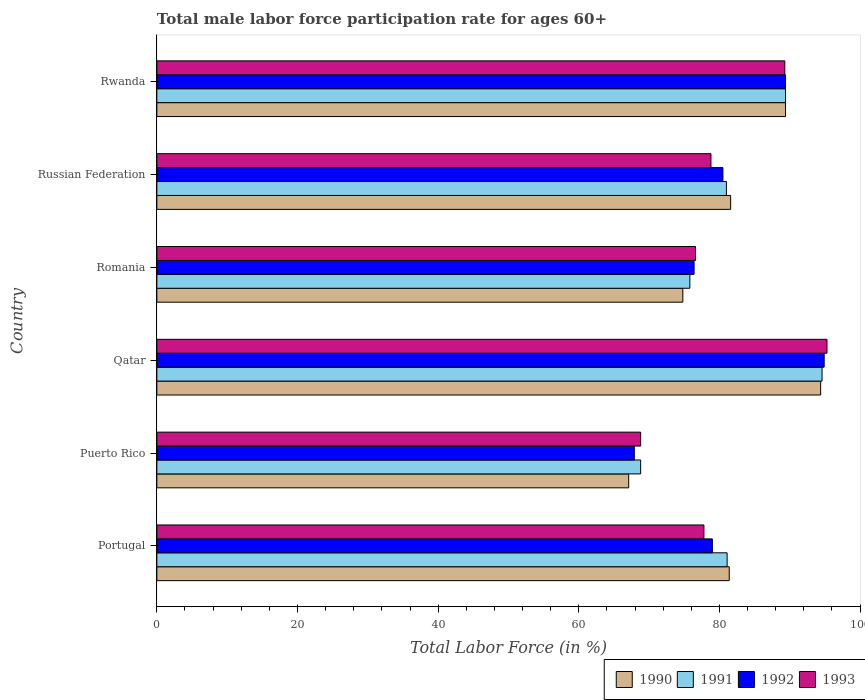How many bars are there on the 5th tick from the top?
Your response must be concise. 4. What is the label of the 1st group of bars from the top?
Ensure brevity in your answer.  Rwanda. What is the male labor force participation rate in 1991 in Portugal?
Your answer should be compact. 81.1. Across all countries, what is the maximum male labor force participation rate in 1991?
Give a very brief answer. 94.6. Across all countries, what is the minimum male labor force participation rate in 1992?
Provide a short and direct response. 67.9. In which country was the male labor force participation rate in 1990 maximum?
Provide a short and direct response. Qatar. In which country was the male labor force participation rate in 1992 minimum?
Keep it short and to the point. Puerto Rico. What is the total male labor force participation rate in 1991 in the graph?
Give a very brief answer. 490.7. What is the difference between the male labor force participation rate in 1990 in Qatar and that in Rwanda?
Make the answer very short. 5. What is the difference between the male labor force participation rate in 1993 in Puerto Rico and the male labor force participation rate in 1991 in Rwanda?
Your answer should be compact. -20.6. What is the average male labor force participation rate in 1992 per country?
Make the answer very short. 81.35. What is the difference between the male labor force participation rate in 1993 and male labor force participation rate in 1990 in Qatar?
Offer a terse response. 0.9. In how many countries, is the male labor force participation rate in 1993 greater than 24 %?
Your answer should be very brief. 6. What is the ratio of the male labor force participation rate in 1992 in Romania to that in Russian Federation?
Your answer should be very brief. 0.95. Is the male labor force participation rate in 1991 in Puerto Rico less than that in Russian Federation?
Keep it short and to the point. Yes. Is the difference between the male labor force participation rate in 1993 in Qatar and Romania greater than the difference between the male labor force participation rate in 1990 in Qatar and Romania?
Offer a very short reply. No. What is the difference between the highest and the lowest male labor force participation rate in 1992?
Provide a short and direct response. 27. What does the 4th bar from the top in Rwanda represents?
Provide a succinct answer. 1990. How many countries are there in the graph?
Offer a terse response. 6. What is the difference between two consecutive major ticks on the X-axis?
Make the answer very short. 20. Does the graph contain grids?
Offer a terse response. No. What is the title of the graph?
Offer a terse response. Total male labor force participation rate for ages 60+. What is the label or title of the X-axis?
Keep it short and to the point. Total Labor Force (in %). What is the Total Labor Force (in %) in 1990 in Portugal?
Your answer should be very brief. 81.4. What is the Total Labor Force (in %) of 1991 in Portugal?
Provide a short and direct response. 81.1. What is the Total Labor Force (in %) of 1992 in Portugal?
Your answer should be compact. 79. What is the Total Labor Force (in %) of 1993 in Portugal?
Provide a short and direct response. 77.8. What is the Total Labor Force (in %) of 1990 in Puerto Rico?
Offer a terse response. 67.1. What is the Total Labor Force (in %) in 1991 in Puerto Rico?
Provide a succinct answer. 68.8. What is the Total Labor Force (in %) in 1992 in Puerto Rico?
Keep it short and to the point. 67.9. What is the Total Labor Force (in %) of 1993 in Puerto Rico?
Your answer should be compact. 68.8. What is the Total Labor Force (in %) in 1990 in Qatar?
Your response must be concise. 94.4. What is the Total Labor Force (in %) in 1991 in Qatar?
Your answer should be compact. 94.6. What is the Total Labor Force (in %) in 1992 in Qatar?
Your response must be concise. 94.9. What is the Total Labor Force (in %) in 1993 in Qatar?
Your answer should be compact. 95.3. What is the Total Labor Force (in %) in 1990 in Romania?
Provide a succinct answer. 74.8. What is the Total Labor Force (in %) of 1991 in Romania?
Your response must be concise. 75.8. What is the Total Labor Force (in %) of 1992 in Romania?
Provide a short and direct response. 76.4. What is the Total Labor Force (in %) in 1993 in Romania?
Give a very brief answer. 76.6. What is the Total Labor Force (in %) in 1990 in Russian Federation?
Your response must be concise. 81.6. What is the Total Labor Force (in %) of 1991 in Russian Federation?
Ensure brevity in your answer.  81. What is the Total Labor Force (in %) in 1992 in Russian Federation?
Ensure brevity in your answer.  80.5. What is the Total Labor Force (in %) in 1993 in Russian Federation?
Provide a succinct answer. 78.8. What is the Total Labor Force (in %) of 1990 in Rwanda?
Provide a short and direct response. 89.4. What is the Total Labor Force (in %) of 1991 in Rwanda?
Make the answer very short. 89.4. What is the Total Labor Force (in %) of 1992 in Rwanda?
Your answer should be very brief. 89.4. What is the Total Labor Force (in %) in 1993 in Rwanda?
Provide a succinct answer. 89.3. Across all countries, what is the maximum Total Labor Force (in %) in 1990?
Your response must be concise. 94.4. Across all countries, what is the maximum Total Labor Force (in %) of 1991?
Give a very brief answer. 94.6. Across all countries, what is the maximum Total Labor Force (in %) in 1992?
Ensure brevity in your answer.  94.9. Across all countries, what is the maximum Total Labor Force (in %) of 1993?
Provide a short and direct response. 95.3. Across all countries, what is the minimum Total Labor Force (in %) of 1990?
Your answer should be compact. 67.1. Across all countries, what is the minimum Total Labor Force (in %) of 1991?
Your response must be concise. 68.8. Across all countries, what is the minimum Total Labor Force (in %) of 1992?
Give a very brief answer. 67.9. Across all countries, what is the minimum Total Labor Force (in %) of 1993?
Provide a short and direct response. 68.8. What is the total Total Labor Force (in %) of 1990 in the graph?
Keep it short and to the point. 488.7. What is the total Total Labor Force (in %) of 1991 in the graph?
Offer a very short reply. 490.7. What is the total Total Labor Force (in %) of 1992 in the graph?
Keep it short and to the point. 488.1. What is the total Total Labor Force (in %) of 1993 in the graph?
Ensure brevity in your answer.  486.6. What is the difference between the Total Labor Force (in %) of 1993 in Portugal and that in Puerto Rico?
Keep it short and to the point. 9. What is the difference between the Total Labor Force (in %) of 1991 in Portugal and that in Qatar?
Your answer should be very brief. -13.5. What is the difference between the Total Labor Force (in %) in 1992 in Portugal and that in Qatar?
Your response must be concise. -15.9. What is the difference between the Total Labor Force (in %) in 1993 in Portugal and that in Qatar?
Make the answer very short. -17.5. What is the difference between the Total Labor Force (in %) of 1990 in Portugal and that in Romania?
Provide a short and direct response. 6.6. What is the difference between the Total Labor Force (in %) in 1990 in Portugal and that in Russian Federation?
Your answer should be very brief. -0.2. What is the difference between the Total Labor Force (in %) of 1990 in Portugal and that in Rwanda?
Make the answer very short. -8. What is the difference between the Total Labor Force (in %) of 1991 in Portugal and that in Rwanda?
Offer a terse response. -8.3. What is the difference between the Total Labor Force (in %) in 1990 in Puerto Rico and that in Qatar?
Make the answer very short. -27.3. What is the difference between the Total Labor Force (in %) of 1991 in Puerto Rico and that in Qatar?
Ensure brevity in your answer.  -25.8. What is the difference between the Total Labor Force (in %) in 1992 in Puerto Rico and that in Qatar?
Your response must be concise. -27. What is the difference between the Total Labor Force (in %) in 1993 in Puerto Rico and that in Qatar?
Give a very brief answer. -26.5. What is the difference between the Total Labor Force (in %) of 1991 in Puerto Rico and that in Romania?
Make the answer very short. -7. What is the difference between the Total Labor Force (in %) in 1992 in Puerto Rico and that in Romania?
Offer a very short reply. -8.5. What is the difference between the Total Labor Force (in %) of 1993 in Puerto Rico and that in Romania?
Give a very brief answer. -7.8. What is the difference between the Total Labor Force (in %) in 1991 in Puerto Rico and that in Russian Federation?
Offer a very short reply. -12.2. What is the difference between the Total Labor Force (in %) in 1992 in Puerto Rico and that in Russian Federation?
Your answer should be compact. -12.6. What is the difference between the Total Labor Force (in %) of 1990 in Puerto Rico and that in Rwanda?
Provide a succinct answer. -22.3. What is the difference between the Total Labor Force (in %) of 1991 in Puerto Rico and that in Rwanda?
Provide a short and direct response. -20.6. What is the difference between the Total Labor Force (in %) of 1992 in Puerto Rico and that in Rwanda?
Your response must be concise. -21.5. What is the difference between the Total Labor Force (in %) in 1993 in Puerto Rico and that in Rwanda?
Offer a very short reply. -20.5. What is the difference between the Total Labor Force (in %) in 1990 in Qatar and that in Romania?
Offer a terse response. 19.6. What is the difference between the Total Labor Force (in %) in 1991 in Qatar and that in Romania?
Your answer should be compact. 18.8. What is the difference between the Total Labor Force (in %) of 1993 in Qatar and that in Romania?
Provide a short and direct response. 18.7. What is the difference between the Total Labor Force (in %) in 1990 in Qatar and that in Russian Federation?
Ensure brevity in your answer.  12.8. What is the difference between the Total Labor Force (in %) in 1992 in Qatar and that in Russian Federation?
Offer a very short reply. 14.4. What is the difference between the Total Labor Force (in %) of 1990 in Qatar and that in Rwanda?
Your answer should be very brief. 5. What is the difference between the Total Labor Force (in %) of 1991 in Qatar and that in Rwanda?
Keep it short and to the point. 5.2. What is the difference between the Total Labor Force (in %) in 1993 in Qatar and that in Rwanda?
Provide a succinct answer. 6. What is the difference between the Total Labor Force (in %) of 1990 in Romania and that in Russian Federation?
Offer a very short reply. -6.8. What is the difference between the Total Labor Force (in %) in 1991 in Romania and that in Russian Federation?
Give a very brief answer. -5.2. What is the difference between the Total Labor Force (in %) in 1992 in Romania and that in Russian Federation?
Make the answer very short. -4.1. What is the difference between the Total Labor Force (in %) in 1990 in Romania and that in Rwanda?
Make the answer very short. -14.6. What is the difference between the Total Labor Force (in %) of 1992 in Romania and that in Rwanda?
Make the answer very short. -13. What is the difference between the Total Labor Force (in %) in 1993 in Romania and that in Rwanda?
Your response must be concise. -12.7. What is the difference between the Total Labor Force (in %) in 1991 in Russian Federation and that in Rwanda?
Keep it short and to the point. -8.4. What is the difference between the Total Labor Force (in %) in 1990 in Portugal and the Total Labor Force (in %) in 1991 in Puerto Rico?
Provide a short and direct response. 12.6. What is the difference between the Total Labor Force (in %) in 1990 in Portugal and the Total Labor Force (in %) in 1993 in Puerto Rico?
Provide a succinct answer. 12.6. What is the difference between the Total Labor Force (in %) of 1991 in Portugal and the Total Labor Force (in %) of 1992 in Puerto Rico?
Your answer should be compact. 13.2. What is the difference between the Total Labor Force (in %) of 1992 in Portugal and the Total Labor Force (in %) of 1993 in Puerto Rico?
Give a very brief answer. 10.2. What is the difference between the Total Labor Force (in %) in 1990 in Portugal and the Total Labor Force (in %) in 1991 in Qatar?
Your answer should be compact. -13.2. What is the difference between the Total Labor Force (in %) in 1990 in Portugal and the Total Labor Force (in %) in 1992 in Qatar?
Provide a succinct answer. -13.5. What is the difference between the Total Labor Force (in %) in 1990 in Portugal and the Total Labor Force (in %) in 1993 in Qatar?
Keep it short and to the point. -13.9. What is the difference between the Total Labor Force (in %) of 1991 in Portugal and the Total Labor Force (in %) of 1992 in Qatar?
Make the answer very short. -13.8. What is the difference between the Total Labor Force (in %) of 1992 in Portugal and the Total Labor Force (in %) of 1993 in Qatar?
Give a very brief answer. -16.3. What is the difference between the Total Labor Force (in %) in 1990 in Portugal and the Total Labor Force (in %) in 1993 in Romania?
Ensure brevity in your answer.  4.8. What is the difference between the Total Labor Force (in %) in 1991 in Portugal and the Total Labor Force (in %) in 1993 in Romania?
Your response must be concise. 4.5. What is the difference between the Total Labor Force (in %) in 1990 in Portugal and the Total Labor Force (in %) in 1991 in Russian Federation?
Give a very brief answer. 0.4. What is the difference between the Total Labor Force (in %) of 1990 in Portugal and the Total Labor Force (in %) of 1992 in Russian Federation?
Offer a very short reply. 0.9. What is the difference between the Total Labor Force (in %) in 1990 in Portugal and the Total Labor Force (in %) in 1993 in Russian Federation?
Keep it short and to the point. 2.6. What is the difference between the Total Labor Force (in %) in 1991 in Portugal and the Total Labor Force (in %) in 1992 in Russian Federation?
Keep it short and to the point. 0.6. What is the difference between the Total Labor Force (in %) in 1990 in Portugal and the Total Labor Force (in %) in 1992 in Rwanda?
Provide a short and direct response. -8. What is the difference between the Total Labor Force (in %) in 1991 in Portugal and the Total Labor Force (in %) in 1993 in Rwanda?
Ensure brevity in your answer.  -8.2. What is the difference between the Total Labor Force (in %) of 1990 in Puerto Rico and the Total Labor Force (in %) of 1991 in Qatar?
Provide a succinct answer. -27.5. What is the difference between the Total Labor Force (in %) in 1990 in Puerto Rico and the Total Labor Force (in %) in 1992 in Qatar?
Ensure brevity in your answer.  -27.8. What is the difference between the Total Labor Force (in %) of 1990 in Puerto Rico and the Total Labor Force (in %) of 1993 in Qatar?
Keep it short and to the point. -28.2. What is the difference between the Total Labor Force (in %) of 1991 in Puerto Rico and the Total Labor Force (in %) of 1992 in Qatar?
Keep it short and to the point. -26.1. What is the difference between the Total Labor Force (in %) in 1991 in Puerto Rico and the Total Labor Force (in %) in 1993 in Qatar?
Offer a terse response. -26.5. What is the difference between the Total Labor Force (in %) of 1992 in Puerto Rico and the Total Labor Force (in %) of 1993 in Qatar?
Your answer should be compact. -27.4. What is the difference between the Total Labor Force (in %) in 1990 in Puerto Rico and the Total Labor Force (in %) in 1992 in Romania?
Your response must be concise. -9.3. What is the difference between the Total Labor Force (in %) of 1991 in Puerto Rico and the Total Labor Force (in %) of 1992 in Romania?
Give a very brief answer. -7.6. What is the difference between the Total Labor Force (in %) in 1991 in Puerto Rico and the Total Labor Force (in %) in 1992 in Russian Federation?
Offer a very short reply. -11.7. What is the difference between the Total Labor Force (in %) of 1992 in Puerto Rico and the Total Labor Force (in %) of 1993 in Russian Federation?
Ensure brevity in your answer.  -10.9. What is the difference between the Total Labor Force (in %) in 1990 in Puerto Rico and the Total Labor Force (in %) in 1991 in Rwanda?
Your answer should be compact. -22.3. What is the difference between the Total Labor Force (in %) of 1990 in Puerto Rico and the Total Labor Force (in %) of 1992 in Rwanda?
Make the answer very short. -22.3. What is the difference between the Total Labor Force (in %) of 1990 in Puerto Rico and the Total Labor Force (in %) of 1993 in Rwanda?
Your answer should be very brief. -22.2. What is the difference between the Total Labor Force (in %) in 1991 in Puerto Rico and the Total Labor Force (in %) in 1992 in Rwanda?
Your answer should be compact. -20.6. What is the difference between the Total Labor Force (in %) of 1991 in Puerto Rico and the Total Labor Force (in %) of 1993 in Rwanda?
Provide a short and direct response. -20.5. What is the difference between the Total Labor Force (in %) of 1992 in Puerto Rico and the Total Labor Force (in %) of 1993 in Rwanda?
Provide a succinct answer. -21.4. What is the difference between the Total Labor Force (in %) of 1990 in Qatar and the Total Labor Force (in %) of 1991 in Romania?
Offer a terse response. 18.6. What is the difference between the Total Labor Force (in %) of 1991 in Qatar and the Total Labor Force (in %) of 1992 in Romania?
Ensure brevity in your answer.  18.2. What is the difference between the Total Labor Force (in %) in 1991 in Qatar and the Total Labor Force (in %) in 1993 in Romania?
Offer a terse response. 18. What is the difference between the Total Labor Force (in %) in 1990 in Qatar and the Total Labor Force (in %) in 1991 in Russian Federation?
Provide a succinct answer. 13.4. What is the difference between the Total Labor Force (in %) of 1990 in Qatar and the Total Labor Force (in %) of 1993 in Russian Federation?
Your answer should be very brief. 15.6. What is the difference between the Total Labor Force (in %) in 1992 in Qatar and the Total Labor Force (in %) in 1993 in Russian Federation?
Your response must be concise. 16.1. What is the difference between the Total Labor Force (in %) in 1990 in Qatar and the Total Labor Force (in %) in 1992 in Rwanda?
Keep it short and to the point. 5. What is the difference between the Total Labor Force (in %) of 1991 in Qatar and the Total Labor Force (in %) of 1992 in Rwanda?
Offer a very short reply. 5.2. What is the difference between the Total Labor Force (in %) in 1991 in Qatar and the Total Labor Force (in %) in 1993 in Rwanda?
Offer a terse response. 5.3. What is the difference between the Total Labor Force (in %) of 1992 in Qatar and the Total Labor Force (in %) of 1993 in Rwanda?
Offer a terse response. 5.6. What is the difference between the Total Labor Force (in %) of 1990 in Romania and the Total Labor Force (in %) of 1992 in Russian Federation?
Ensure brevity in your answer.  -5.7. What is the difference between the Total Labor Force (in %) in 1991 in Romania and the Total Labor Force (in %) in 1992 in Russian Federation?
Keep it short and to the point. -4.7. What is the difference between the Total Labor Force (in %) of 1992 in Romania and the Total Labor Force (in %) of 1993 in Russian Federation?
Your response must be concise. -2.4. What is the difference between the Total Labor Force (in %) in 1990 in Romania and the Total Labor Force (in %) in 1991 in Rwanda?
Your answer should be compact. -14.6. What is the difference between the Total Labor Force (in %) of 1990 in Romania and the Total Labor Force (in %) of 1992 in Rwanda?
Your answer should be very brief. -14.6. What is the difference between the Total Labor Force (in %) in 1991 in Romania and the Total Labor Force (in %) in 1992 in Rwanda?
Your answer should be compact. -13.6. What is the difference between the Total Labor Force (in %) in 1991 in Romania and the Total Labor Force (in %) in 1993 in Rwanda?
Provide a succinct answer. -13.5. What is the difference between the Total Labor Force (in %) of 1990 in Russian Federation and the Total Labor Force (in %) of 1991 in Rwanda?
Your answer should be compact. -7.8. What is the difference between the Total Labor Force (in %) in 1991 in Russian Federation and the Total Labor Force (in %) in 1992 in Rwanda?
Make the answer very short. -8.4. What is the difference between the Total Labor Force (in %) of 1991 in Russian Federation and the Total Labor Force (in %) of 1993 in Rwanda?
Your answer should be compact. -8.3. What is the difference between the Total Labor Force (in %) in 1992 in Russian Federation and the Total Labor Force (in %) in 1993 in Rwanda?
Offer a very short reply. -8.8. What is the average Total Labor Force (in %) in 1990 per country?
Your answer should be compact. 81.45. What is the average Total Labor Force (in %) of 1991 per country?
Provide a short and direct response. 81.78. What is the average Total Labor Force (in %) in 1992 per country?
Offer a terse response. 81.35. What is the average Total Labor Force (in %) in 1993 per country?
Your response must be concise. 81.1. What is the difference between the Total Labor Force (in %) of 1990 and Total Labor Force (in %) of 1991 in Portugal?
Provide a succinct answer. 0.3. What is the difference between the Total Labor Force (in %) of 1990 and Total Labor Force (in %) of 1992 in Portugal?
Offer a very short reply. 2.4. What is the difference between the Total Labor Force (in %) in 1991 and Total Labor Force (in %) in 1992 in Portugal?
Your answer should be very brief. 2.1. What is the difference between the Total Labor Force (in %) in 1990 and Total Labor Force (in %) in 1993 in Puerto Rico?
Give a very brief answer. -1.7. What is the difference between the Total Labor Force (in %) of 1991 and Total Labor Force (in %) of 1992 in Puerto Rico?
Offer a very short reply. 0.9. What is the difference between the Total Labor Force (in %) of 1992 and Total Labor Force (in %) of 1993 in Puerto Rico?
Provide a short and direct response. -0.9. What is the difference between the Total Labor Force (in %) in 1990 and Total Labor Force (in %) in 1992 in Qatar?
Provide a short and direct response. -0.5. What is the difference between the Total Labor Force (in %) in 1991 and Total Labor Force (in %) in 1993 in Qatar?
Your answer should be very brief. -0.7. What is the difference between the Total Labor Force (in %) of 1990 and Total Labor Force (in %) of 1991 in Romania?
Provide a succinct answer. -1. What is the difference between the Total Labor Force (in %) in 1990 and Total Labor Force (in %) in 1993 in Romania?
Your response must be concise. -1.8. What is the difference between the Total Labor Force (in %) in 1991 and Total Labor Force (in %) in 1992 in Romania?
Provide a succinct answer. -0.6. What is the difference between the Total Labor Force (in %) in 1991 and Total Labor Force (in %) in 1993 in Romania?
Your answer should be compact. -0.8. What is the difference between the Total Labor Force (in %) in 1992 and Total Labor Force (in %) in 1993 in Romania?
Provide a succinct answer. -0.2. What is the difference between the Total Labor Force (in %) of 1990 and Total Labor Force (in %) of 1993 in Russian Federation?
Your answer should be very brief. 2.8. What is the difference between the Total Labor Force (in %) in 1990 and Total Labor Force (in %) in 1991 in Rwanda?
Make the answer very short. 0. What is the difference between the Total Labor Force (in %) of 1990 and Total Labor Force (in %) of 1992 in Rwanda?
Provide a short and direct response. 0. What is the difference between the Total Labor Force (in %) in 1991 and Total Labor Force (in %) in 1993 in Rwanda?
Make the answer very short. 0.1. What is the difference between the Total Labor Force (in %) in 1992 and Total Labor Force (in %) in 1993 in Rwanda?
Offer a very short reply. 0.1. What is the ratio of the Total Labor Force (in %) of 1990 in Portugal to that in Puerto Rico?
Your answer should be compact. 1.21. What is the ratio of the Total Labor Force (in %) in 1991 in Portugal to that in Puerto Rico?
Offer a very short reply. 1.18. What is the ratio of the Total Labor Force (in %) of 1992 in Portugal to that in Puerto Rico?
Your answer should be compact. 1.16. What is the ratio of the Total Labor Force (in %) in 1993 in Portugal to that in Puerto Rico?
Keep it short and to the point. 1.13. What is the ratio of the Total Labor Force (in %) of 1990 in Portugal to that in Qatar?
Make the answer very short. 0.86. What is the ratio of the Total Labor Force (in %) of 1991 in Portugal to that in Qatar?
Your answer should be very brief. 0.86. What is the ratio of the Total Labor Force (in %) of 1992 in Portugal to that in Qatar?
Offer a very short reply. 0.83. What is the ratio of the Total Labor Force (in %) of 1993 in Portugal to that in Qatar?
Offer a terse response. 0.82. What is the ratio of the Total Labor Force (in %) of 1990 in Portugal to that in Romania?
Ensure brevity in your answer.  1.09. What is the ratio of the Total Labor Force (in %) of 1991 in Portugal to that in Romania?
Your response must be concise. 1.07. What is the ratio of the Total Labor Force (in %) of 1992 in Portugal to that in Romania?
Your response must be concise. 1.03. What is the ratio of the Total Labor Force (in %) of 1993 in Portugal to that in Romania?
Make the answer very short. 1.02. What is the ratio of the Total Labor Force (in %) of 1990 in Portugal to that in Russian Federation?
Your response must be concise. 1. What is the ratio of the Total Labor Force (in %) in 1991 in Portugal to that in Russian Federation?
Your answer should be compact. 1. What is the ratio of the Total Labor Force (in %) in 1992 in Portugal to that in Russian Federation?
Offer a terse response. 0.98. What is the ratio of the Total Labor Force (in %) in 1993 in Portugal to that in Russian Federation?
Your answer should be compact. 0.99. What is the ratio of the Total Labor Force (in %) in 1990 in Portugal to that in Rwanda?
Make the answer very short. 0.91. What is the ratio of the Total Labor Force (in %) of 1991 in Portugal to that in Rwanda?
Provide a succinct answer. 0.91. What is the ratio of the Total Labor Force (in %) in 1992 in Portugal to that in Rwanda?
Your answer should be very brief. 0.88. What is the ratio of the Total Labor Force (in %) in 1993 in Portugal to that in Rwanda?
Provide a succinct answer. 0.87. What is the ratio of the Total Labor Force (in %) of 1990 in Puerto Rico to that in Qatar?
Your response must be concise. 0.71. What is the ratio of the Total Labor Force (in %) of 1991 in Puerto Rico to that in Qatar?
Ensure brevity in your answer.  0.73. What is the ratio of the Total Labor Force (in %) of 1992 in Puerto Rico to that in Qatar?
Offer a very short reply. 0.72. What is the ratio of the Total Labor Force (in %) in 1993 in Puerto Rico to that in Qatar?
Provide a succinct answer. 0.72. What is the ratio of the Total Labor Force (in %) in 1990 in Puerto Rico to that in Romania?
Offer a very short reply. 0.9. What is the ratio of the Total Labor Force (in %) of 1991 in Puerto Rico to that in Romania?
Offer a terse response. 0.91. What is the ratio of the Total Labor Force (in %) of 1992 in Puerto Rico to that in Romania?
Provide a succinct answer. 0.89. What is the ratio of the Total Labor Force (in %) of 1993 in Puerto Rico to that in Romania?
Ensure brevity in your answer.  0.9. What is the ratio of the Total Labor Force (in %) in 1990 in Puerto Rico to that in Russian Federation?
Give a very brief answer. 0.82. What is the ratio of the Total Labor Force (in %) in 1991 in Puerto Rico to that in Russian Federation?
Keep it short and to the point. 0.85. What is the ratio of the Total Labor Force (in %) in 1992 in Puerto Rico to that in Russian Federation?
Ensure brevity in your answer.  0.84. What is the ratio of the Total Labor Force (in %) of 1993 in Puerto Rico to that in Russian Federation?
Ensure brevity in your answer.  0.87. What is the ratio of the Total Labor Force (in %) in 1990 in Puerto Rico to that in Rwanda?
Your answer should be very brief. 0.75. What is the ratio of the Total Labor Force (in %) in 1991 in Puerto Rico to that in Rwanda?
Your answer should be compact. 0.77. What is the ratio of the Total Labor Force (in %) of 1992 in Puerto Rico to that in Rwanda?
Your answer should be very brief. 0.76. What is the ratio of the Total Labor Force (in %) in 1993 in Puerto Rico to that in Rwanda?
Offer a very short reply. 0.77. What is the ratio of the Total Labor Force (in %) in 1990 in Qatar to that in Romania?
Your response must be concise. 1.26. What is the ratio of the Total Labor Force (in %) in 1991 in Qatar to that in Romania?
Your answer should be very brief. 1.25. What is the ratio of the Total Labor Force (in %) of 1992 in Qatar to that in Romania?
Your response must be concise. 1.24. What is the ratio of the Total Labor Force (in %) in 1993 in Qatar to that in Romania?
Make the answer very short. 1.24. What is the ratio of the Total Labor Force (in %) in 1990 in Qatar to that in Russian Federation?
Your answer should be very brief. 1.16. What is the ratio of the Total Labor Force (in %) in 1991 in Qatar to that in Russian Federation?
Your answer should be very brief. 1.17. What is the ratio of the Total Labor Force (in %) in 1992 in Qatar to that in Russian Federation?
Your response must be concise. 1.18. What is the ratio of the Total Labor Force (in %) of 1993 in Qatar to that in Russian Federation?
Provide a succinct answer. 1.21. What is the ratio of the Total Labor Force (in %) in 1990 in Qatar to that in Rwanda?
Offer a terse response. 1.06. What is the ratio of the Total Labor Force (in %) in 1991 in Qatar to that in Rwanda?
Make the answer very short. 1.06. What is the ratio of the Total Labor Force (in %) in 1992 in Qatar to that in Rwanda?
Offer a very short reply. 1.06. What is the ratio of the Total Labor Force (in %) in 1993 in Qatar to that in Rwanda?
Your answer should be compact. 1.07. What is the ratio of the Total Labor Force (in %) in 1991 in Romania to that in Russian Federation?
Your response must be concise. 0.94. What is the ratio of the Total Labor Force (in %) of 1992 in Romania to that in Russian Federation?
Provide a succinct answer. 0.95. What is the ratio of the Total Labor Force (in %) in 1993 in Romania to that in Russian Federation?
Give a very brief answer. 0.97. What is the ratio of the Total Labor Force (in %) in 1990 in Romania to that in Rwanda?
Keep it short and to the point. 0.84. What is the ratio of the Total Labor Force (in %) of 1991 in Romania to that in Rwanda?
Offer a terse response. 0.85. What is the ratio of the Total Labor Force (in %) of 1992 in Romania to that in Rwanda?
Your answer should be compact. 0.85. What is the ratio of the Total Labor Force (in %) of 1993 in Romania to that in Rwanda?
Offer a terse response. 0.86. What is the ratio of the Total Labor Force (in %) of 1990 in Russian Federation to that in Rwanda?
Your answer should be very brief. 0.91. What is the ratio of the Total Labor Force (in %) of 1991 in Russian Federation to that in Rwanda?
Your response must be concise. 0.91. What is the ratio of the Total Labor Force (in %) in 1992 in Russian Federation to that in Rwanda?
Your answer should be compact. 0.9. What is the ratio of the Total Labor Force (in %) in 1993 in Russian Federation to that in Rwanda?
Ensure brevity in your answer.  0.88. What is the difference between the highest and the second highest Total Labor Force (in %) in 1990?
Provide a short and direct response. 5. What is the difference between the highest and the second highest Total Labor Force (in %) of 1992?
Offer a terse response. 5.5. What is the difference between the highest and the second highest Total Labor Force (in %) of 1993?
Keep it short and to the point. 6. What is the difference between the highest and the lowest Total Labor Force (in %) in 1990?
Keep it short and to the point. 27.3. What is the difference between the highest and the lowest Total Labor Force (in %) in 1991?
Your answer should be very brief. 25.8. What is the difference between the highest and the lowest Total Labor Force (in %) in 1993?
Ensure brevity in your answer.  26.5. 